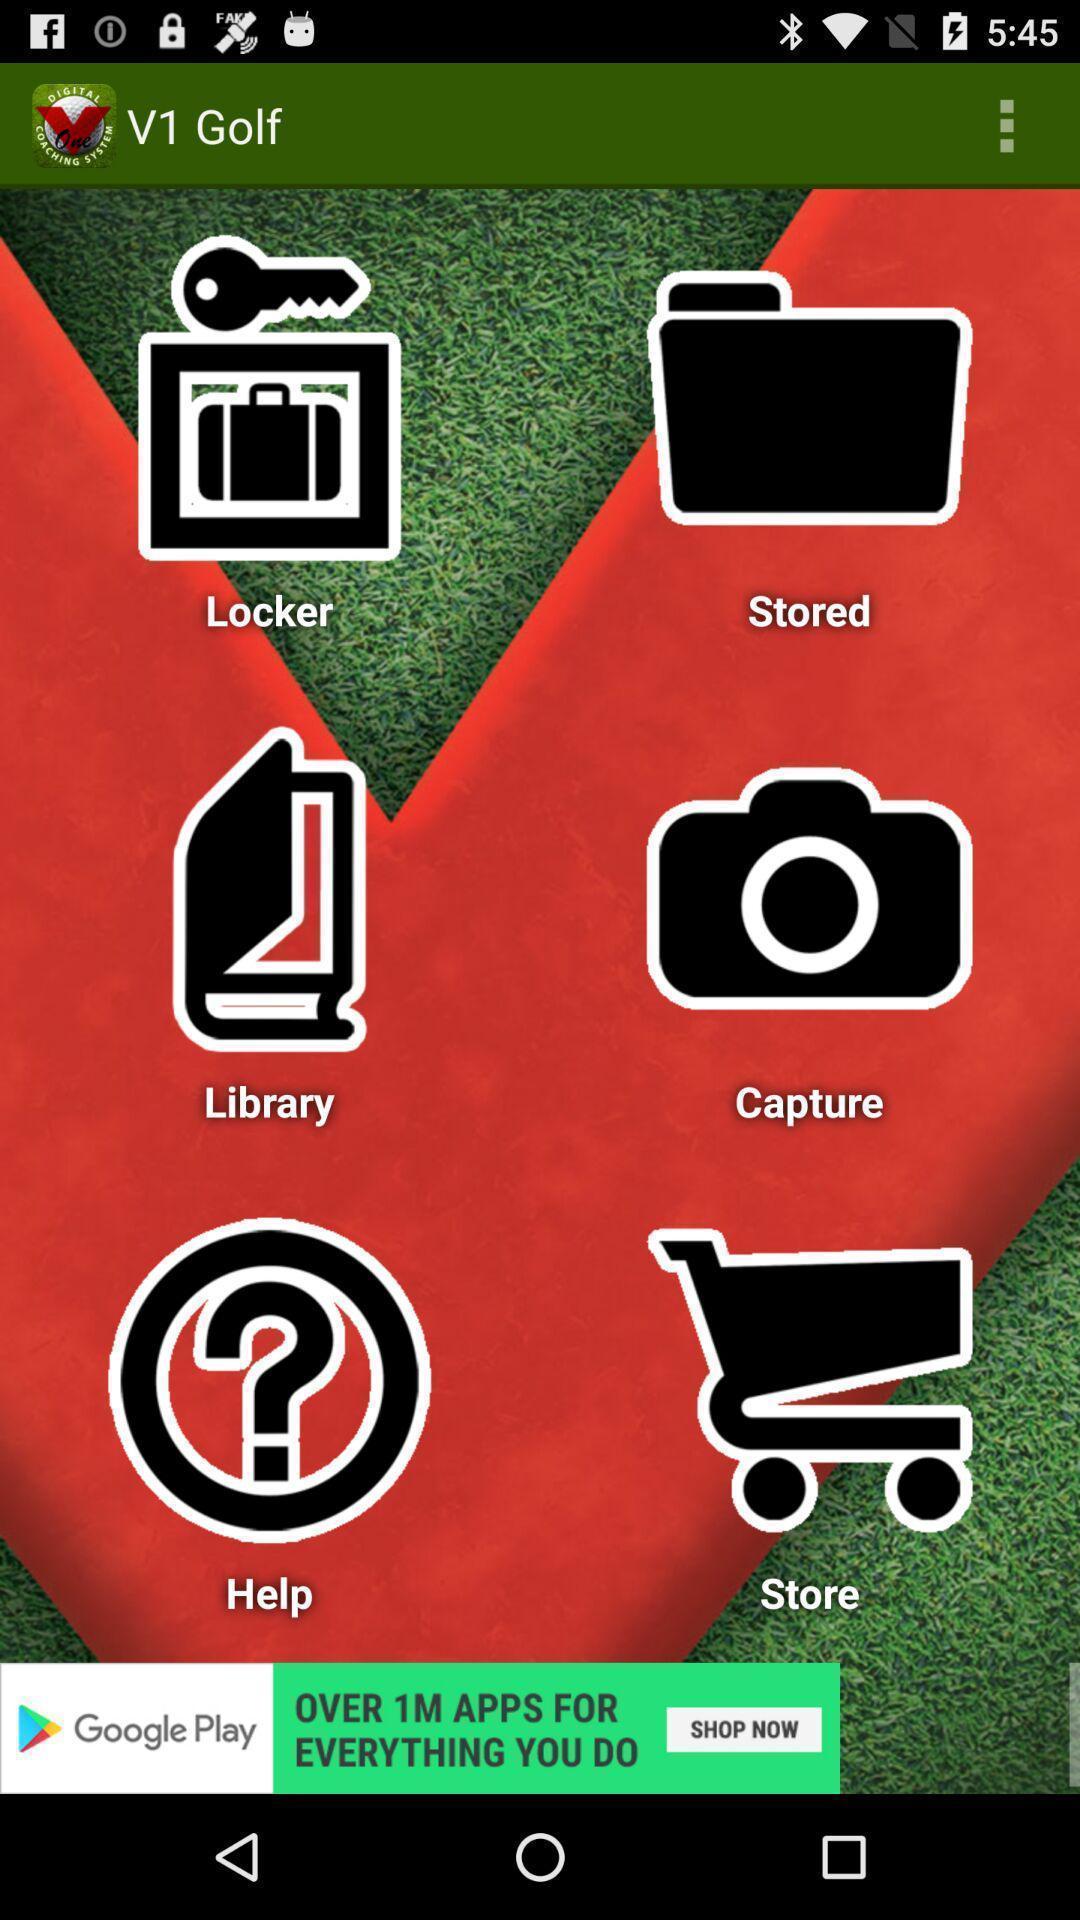Describe the content in this image. Screen displaying list of icons on an app. 